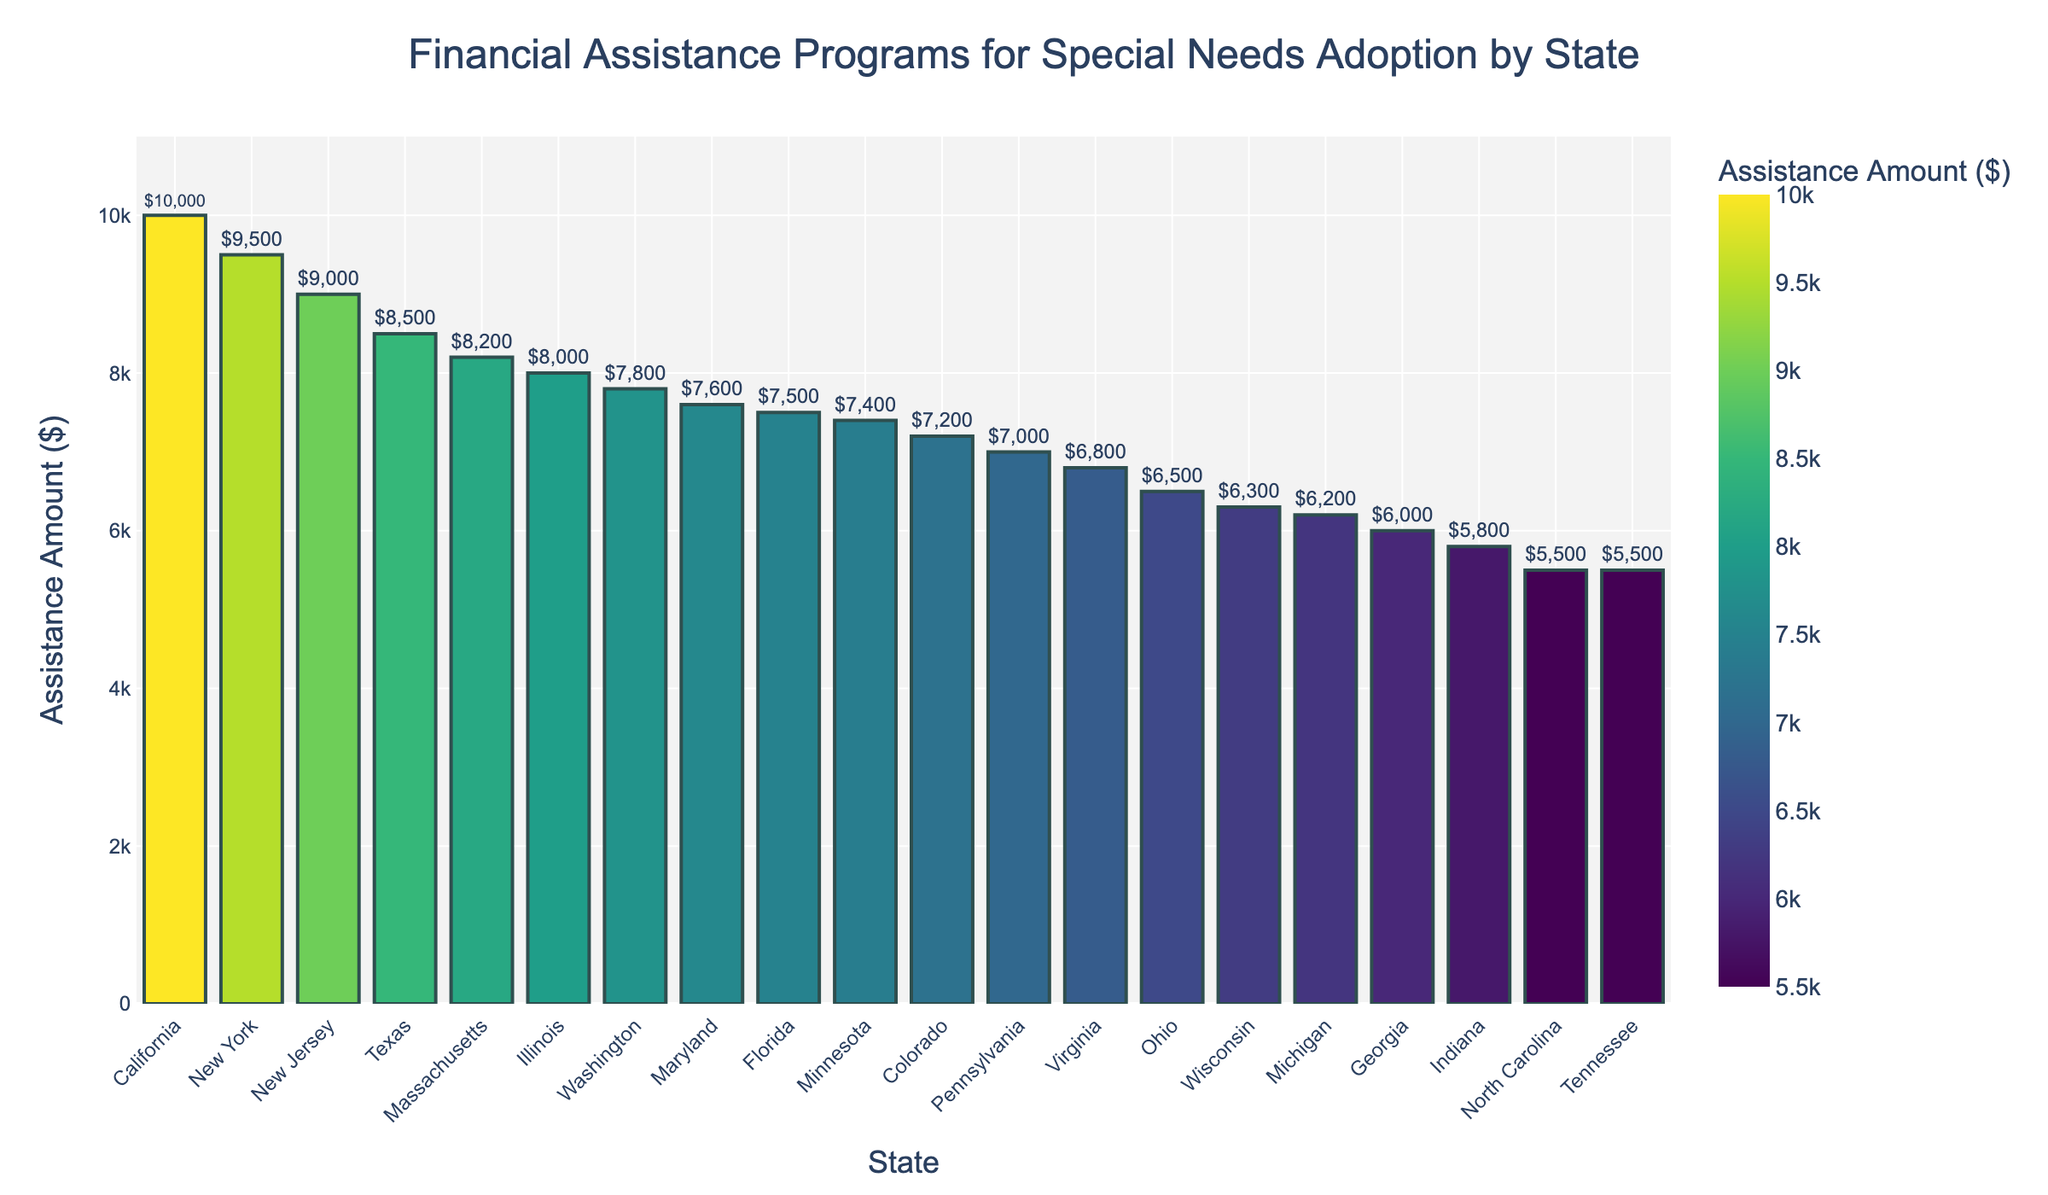Which state offers the highest financial assistance? The highest bar represents the state with the highest financial assistance. It reaches up to $10,000 for California, which is the highest amount among all states listed.
Answer: California What is the financial assistance amount for Texas and New York, and how do they compare to each other? The financial assistance amount for Texas is $8,500, while for New York, it is $9,500. Comparing the two, New York provides $1,000 more assistance than Texas.
Answer: Texas: $8,500, New York: $9,500. New York provides $1,000 more Which states offer financial assistance amounts close to $8,000? Looking at the bars, Illinois offers $8,000 exactly, Massachusetts offers $8,200, and Washington offers $7,800. These are close to the $8,000 mark.
Answer: Illinois, Massachusetts, Washington How much more financial assistance does California offer compared to Georgia? California offers $10,000, while Georgia offers $6,000. The difference is $10,000 - $6,000 = $4,000.
Answer: $4,000 List the states that provide more than $9,000 in financial assistance. From the chart, both California ($10,000) and New York ($9,500), as well as New Jersey ($9,000), provide more than $9,000.
Answer: California, New York, New Jersey What is the average financial assistance amount for the states provided? To find the average, sum all the states' financial assistance and divide by the number of states.
Sum = 10000 + 8500 + 9500 + 7500 + 8000 + 7000 + 6500 + 6000 + 5500 + 6200 + 8200 + 7800 + 6800 + 9000 + 7200 + 5800 + 5500 + 6300 + 7600 + 7400 = 144600.
Number of states = 20.
Average = 144600 / 20 = 7230.
Answer: $7,230 Which state offers the least financial assistance and how much is it? The shortest bar represents Tennessee and North Carolina, both offering $5,500, which is the least amount among the listed states.
Answer: Tennessee, North Carolina; $5,500 What is the total financial assistance provided by Pennsylvania, Ohio, and Virginia combined? Adding the financial assistance amounts for these states: Pennsylvania ($7,000) + Ohio ($6,500) + Virginia ($6,800) = $20,300.
Answer: $20,300 Compare the financial assistance between the states with the median amounts. What are these values? To find the median, list all values in ascending order and find the middle ones. The middle values for 20 states are the 10th and 11th values:
Sorted values: 5500, 5500, 5800, 6000, 6200, 6300, 6500, 6800, 7000, 7200, 7400, 7500, 7600, 7800, 8000, 8200, 8500, 9000, 9500, 10000.
10th value is 7,200 (Colorado) and 11th value is 7,400 (Minnesota).
Median = (7200 + 7400) / 2 = 7300.
Answer: $7,300 